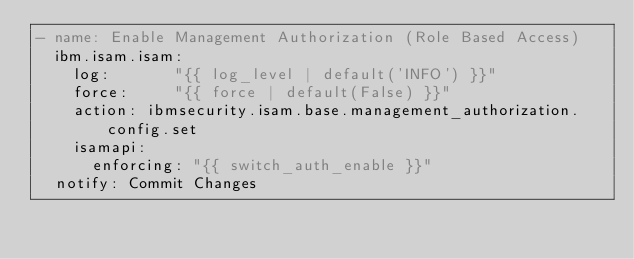<code> <loc_0><loc_0><loc_500><loc_500><_YAML_>- name: Enable Management Authorization (Role Based Access)
  ibm.isam.isam:
    log:       "{{ log_level | default('INFO') }}"
    force:     "{{ force | default(False) }}"
    action: ibmsecurity.isam.base.management_authorization.config.set
    isamapi:
      enforcing: "{{ switch_auth_enable }}"
  notify: Commit Changes
</code> 